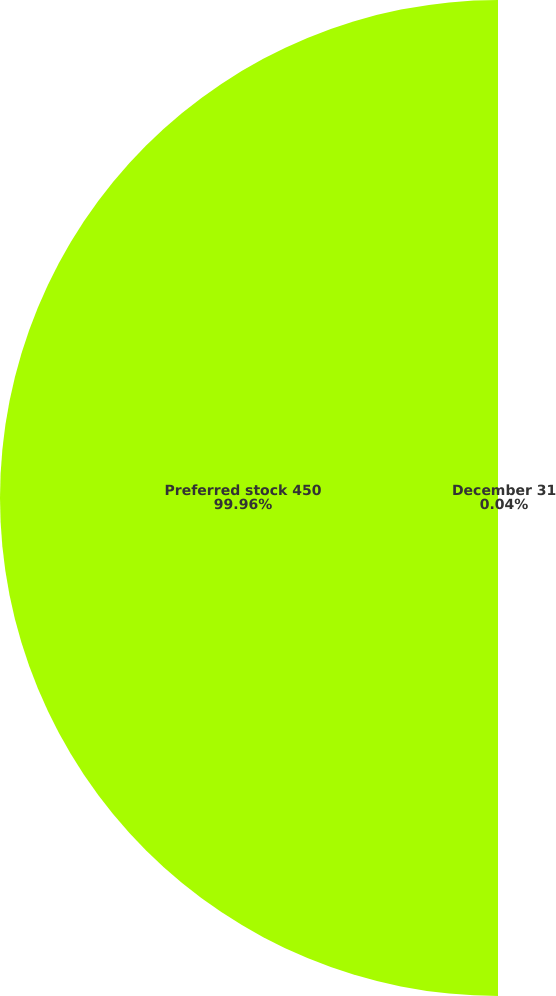<chart> <loc_0><loc_0><loc_500><loc_500><pie_chart><fcel>December 31<fcel>Preferred stock 450<nl><fcel>0.04%<fcel>99.96%<nl></chart> 